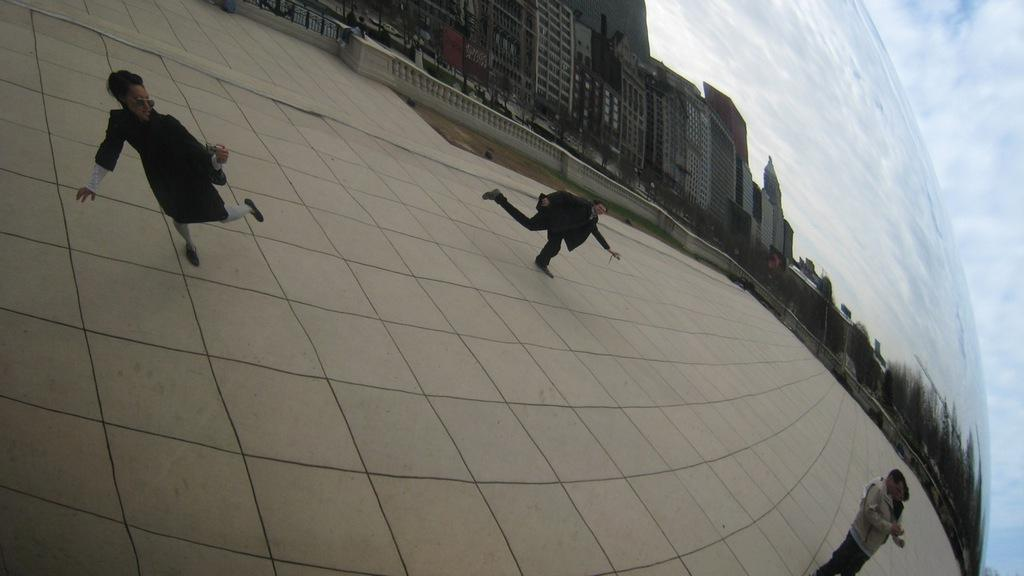What are the persons in the image doing? The persons in the image are walking. On what surface are the persons walking? The persons are walking on a floor. What can be seen in the background of the image? There are buildings and the sky visible in the background. How would you describe the sky in the image? The sky appears to be clear in the image. What type of jewel can be seen on the grass in the image? There is no grass or jewel present in the image. What color is the vest worn by the person walking in the image? There is no person wearing a vest in the image. 